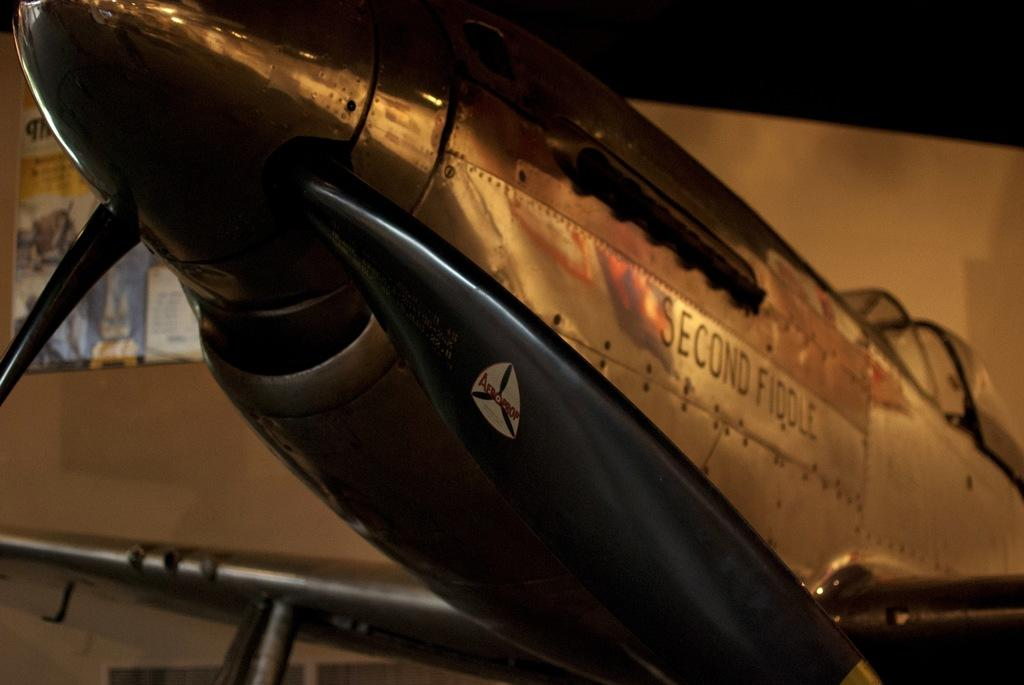Provide a one-sentence caption for the provided image. An airplane named Second Fiddle sits in a dimly lit room. 